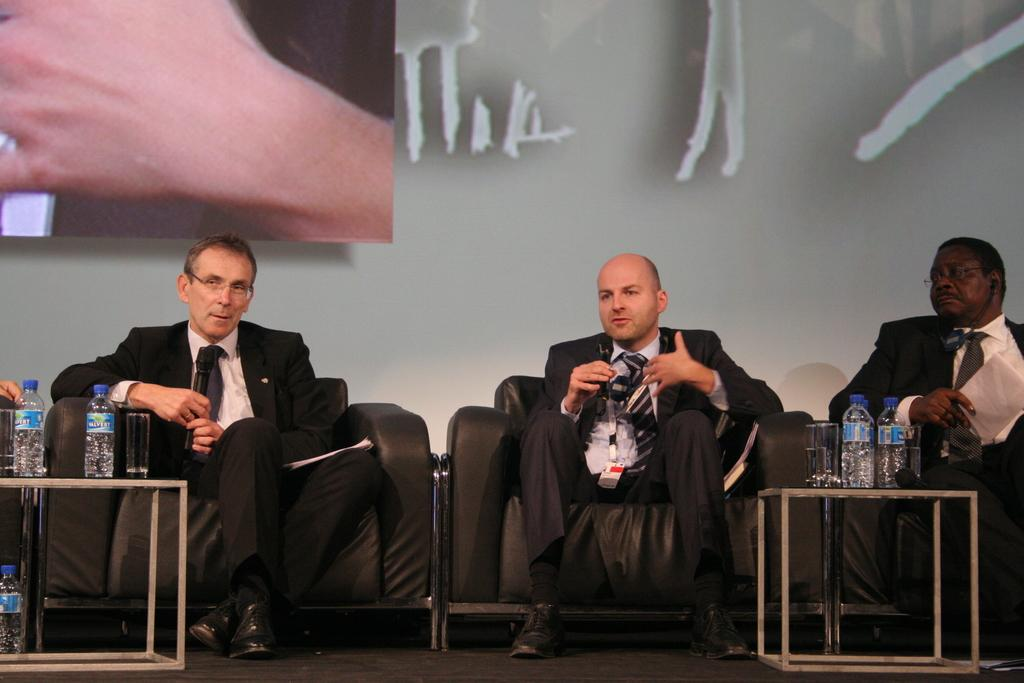What type of furniture is present in the image? There are chairs and tables in the image. What are people doing with the chairs in the image? People are sitting on the chairs in the image. What can be seen on the tables in the image? There are glasses and water bottles on the tables in the image. Is there a stranger wearing a crown in the image? There is no stranger or crown present in the image. How are the people measuring the distance between the chairs in the image? There is no measuring or distance being discussed in the image; people are simply sitting on the chairs. 